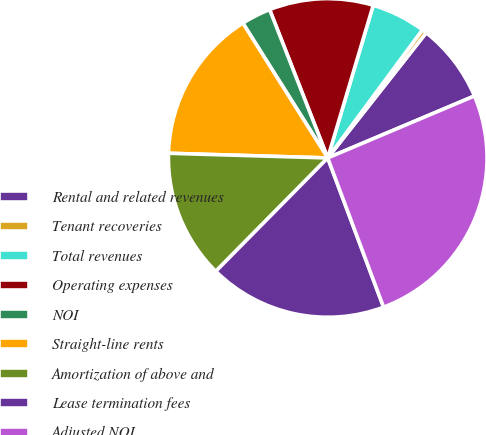Convert chart. <chart><loc_0><loc_0><loc_500><loc_500><pie_chart><fcel>Rental and related revenues<fcel>Tenant recoveries<fcel>Total revenues<fcel>Operating expenses<fcel>NOI<fcel>Straight-line rents<fcel>Amortization of above and<fcel>Lease termination fees<fcel>Adjusted NOI<nl><fcel>8.03%<fcel>0.48%<fcel>5.52%<fcel>10.55%<fcel>3.0%<fcel>15.59%<fcel>13.07%<fcel>18.1%<fcel>25.66%<nl></chart> 